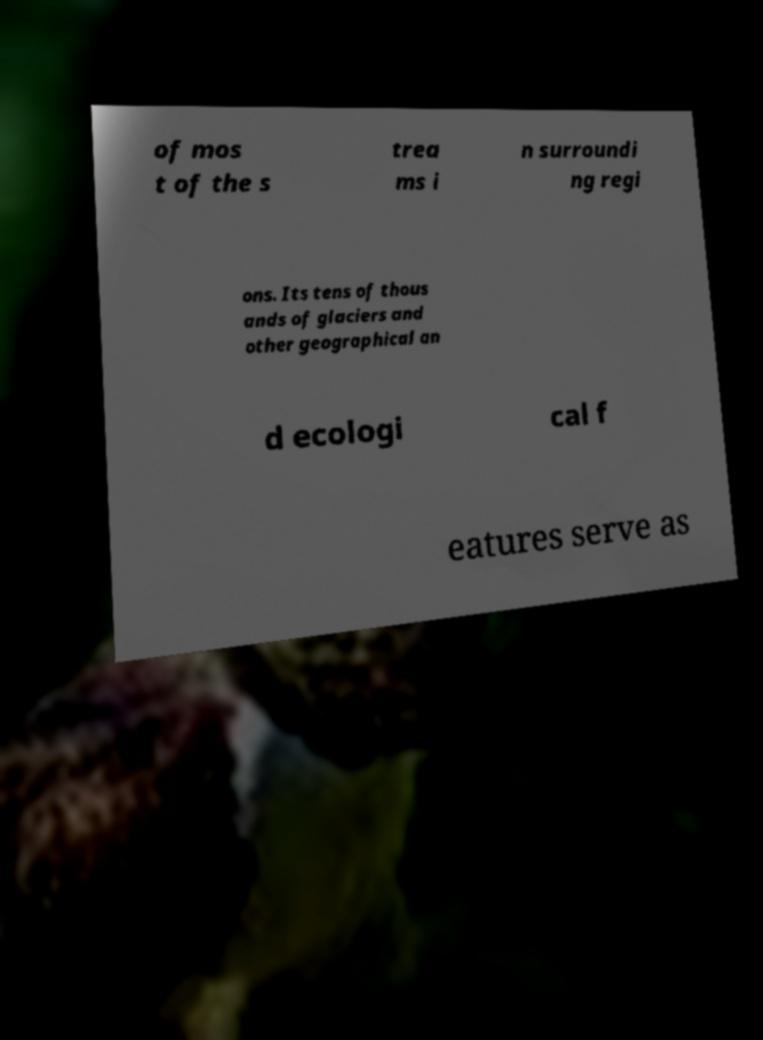Could you assist in decoding the text presented in this image and type it out clearly? of mos t of the s trea ms i n surroundi ng regi ons. Its tens of thous ands of glaciers and other geographical an d ecologi cal f eatures serve as 